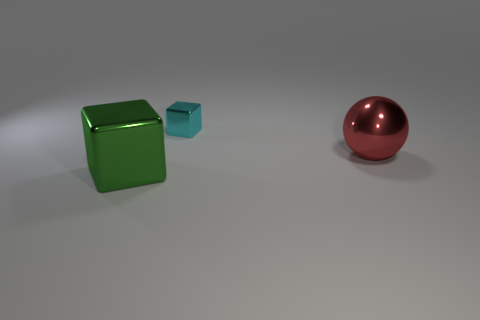Add 2 large purple shiny cylinders. How many objects exist? 5 Subtract all blocks. How many objects are left? 1 Subtract all tiny things. Subtract all red shiny objects. How many objects are left? 1 Add 1 small blocks. How many small blocks are left? 2 Add 3 big things. How many big things exist? 5 Subtract 0 cyan cylinders. How many objects are left? 3 